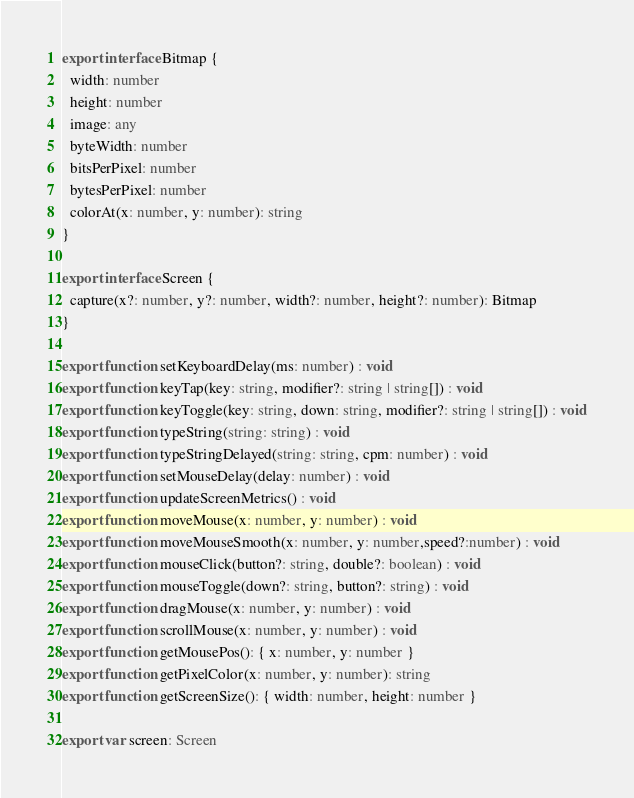Convert code to text. <code><loc_0><loc_0><loc_500><loc_500><_TypeScript_>export interface Bitmap {
  width: number
  height: number
  image: any
  byteWidth: number
  bitsPerPixel: number
  bytesPerPixel: number
  colorAt(x: number, y: number): string
}

export interface Screen {
  capture(x?: number, y?: number, width?: number, height?: number): Bitmap
}

export function setKeyboardDelay(ms: number) : void
export function keyTap(key: string, modifier?: string | string[]) : void
export function keyToggle(key: string, down: string, modifier?: string | string[]) : void
export function typeString(string: string) : void
export function typeStringDelayed(string: string, cpm: number) : void
export function setMouseDelay(delay: number) : void
export function updateScreenMetrics() : void
export function moveMouse(x: number, y: number) : void
export function moveMouseSmooth(x: number, y: number,speed?:number) : void
export function mouseClick(button?: string, double?: boolean) : void
export function mouseToggle(down?: string, button?: string) : void
export function dragMouse(x: number, y: number) : void
export function scrollMouse(x: number, y: number) : void
export function getMousePos(): { x: number, y: number }
export function getPixelColor(x: number, y: number): string
export function getScreenSize(): { width: number, height: number }

export var screen: Screen
</code> 